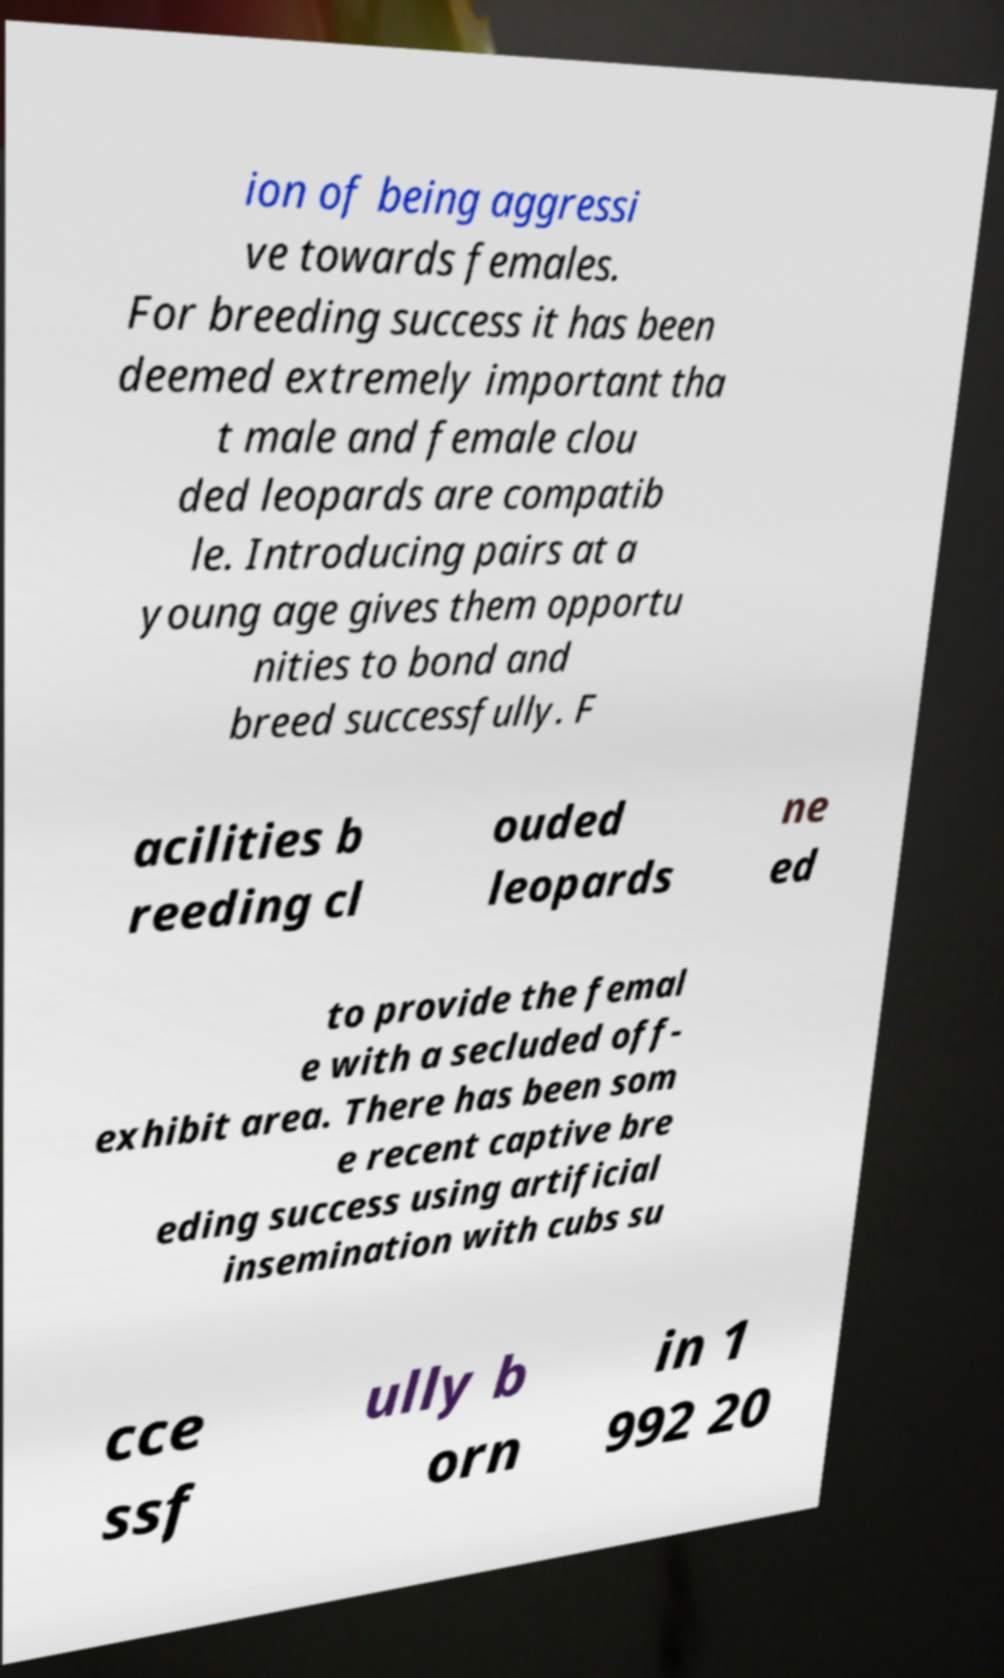Please read and relay the text visible in this image. What does it say? ion of being aggressi ve towards females. For breeding success it has been deemed extremely important tha t male and female clou ded leopards are compatib le. Introducing pairs at a young age gives them opportu nities to bond and breed successfully. F acilities b reeding cl ouded leopards ne ed to provide the femal e with a secluded off- exhibit area. There has been som e recent captive bre eding success using artificial insemination with cubs su cce ssf ully b orn in 1 992 20 